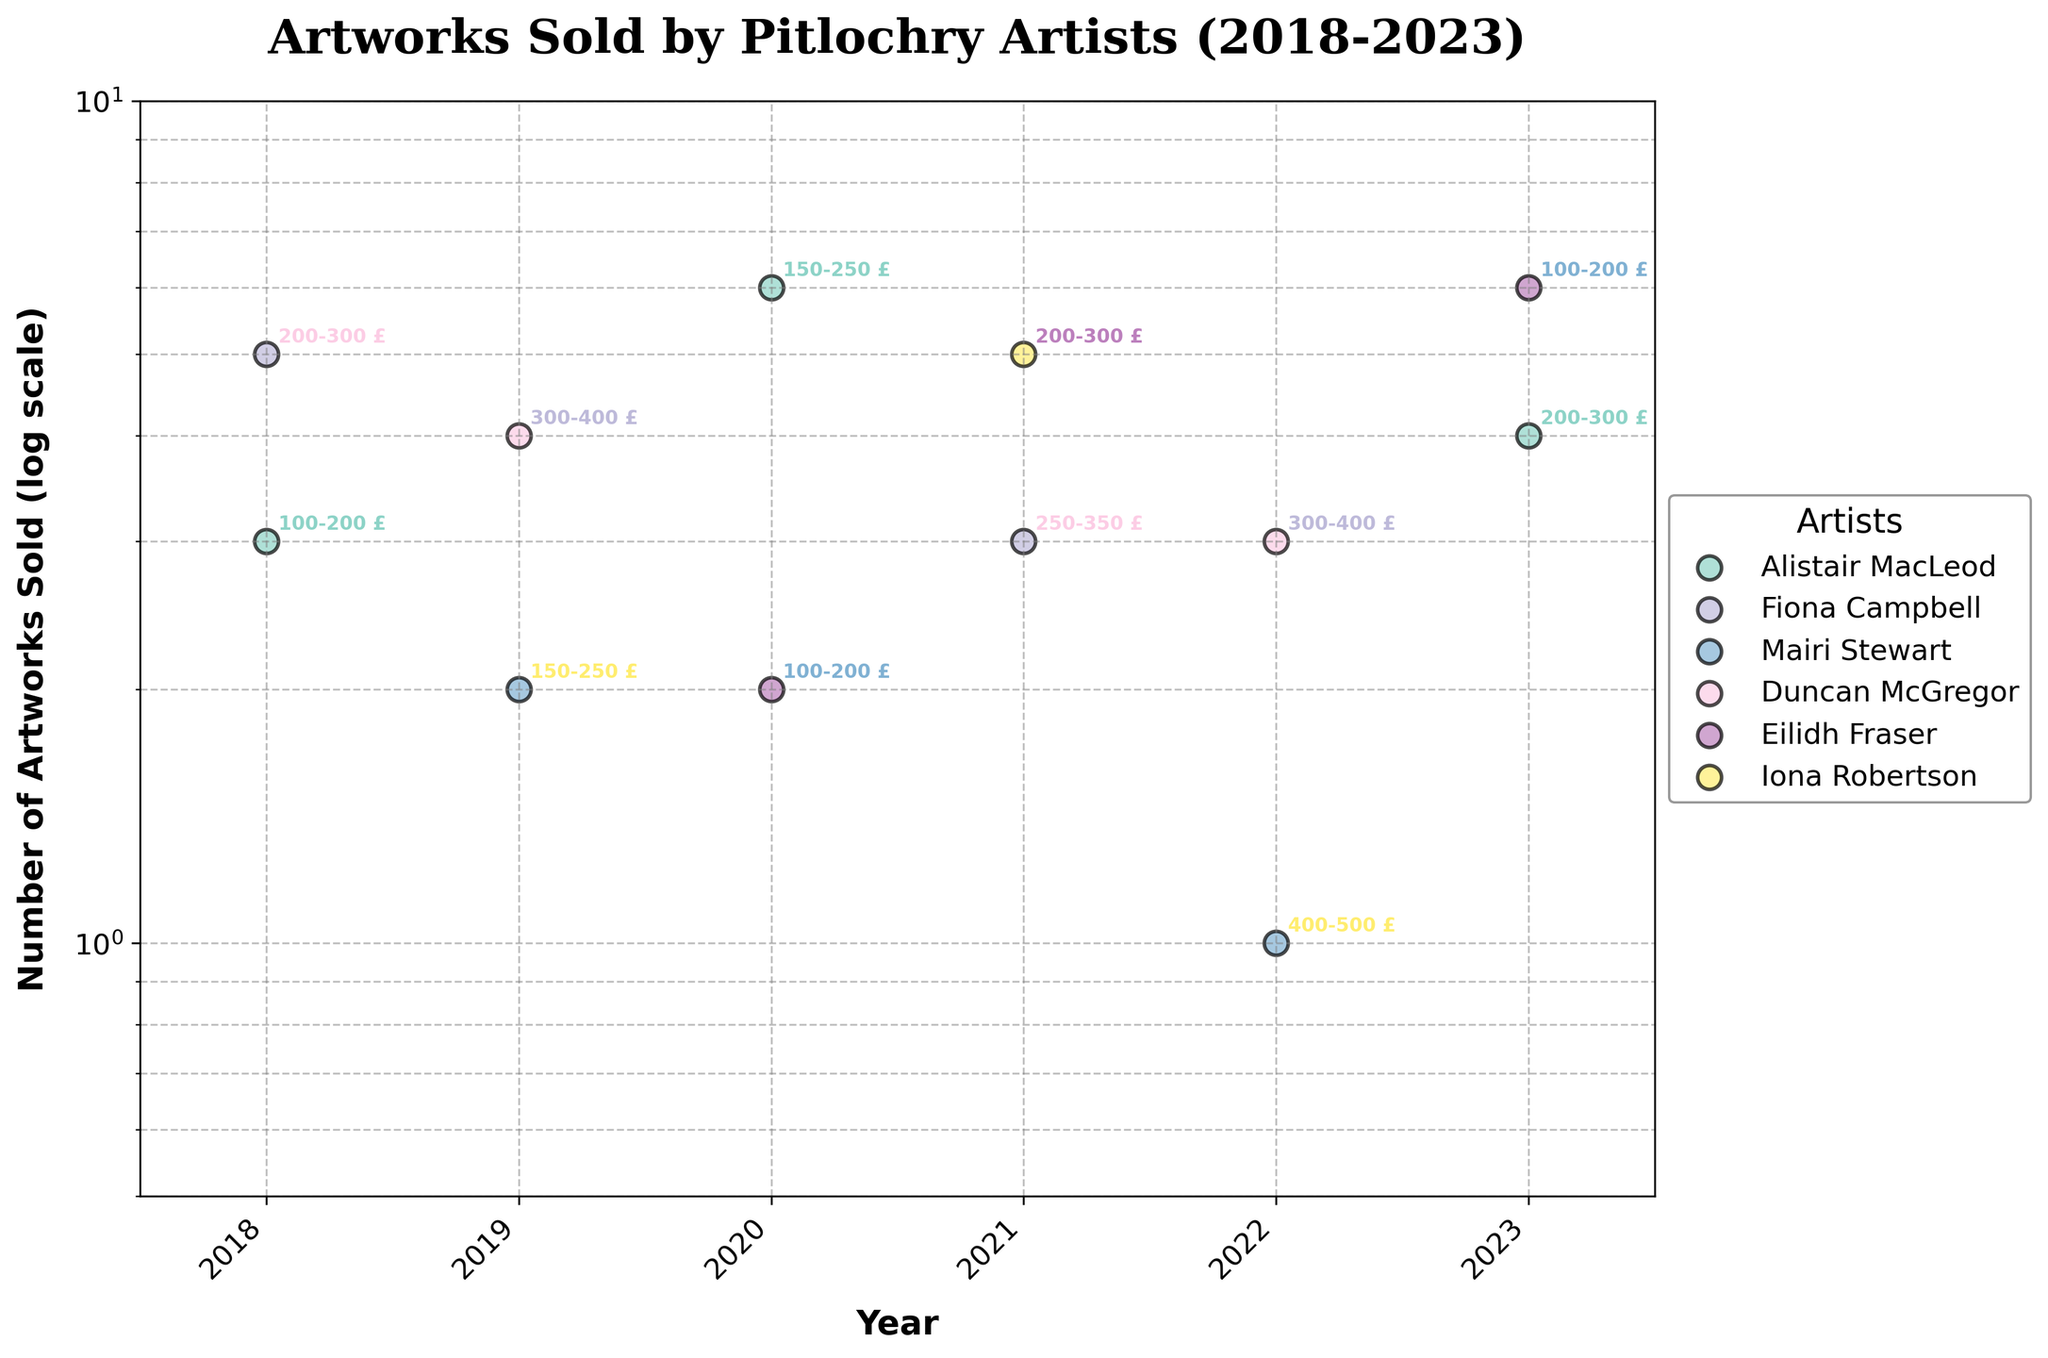what is the title of the figure? The title is usually positioned at the top of the figure in bold font. Here, the title is displayed as "Artworks Sold by Pitlochry Artists (2018-2023)", indicating the content and the time frame.
Answer: Artworks Sold by Pitlochry Artists (2018-2023) What is the value range of the log scale on the y-axis? By looking at the y-axis labels, we can see the numerical range, which starts from 0.5 and goes up to 10. This indicates the number of artworks sold on a log scale.
Answer: 0.5 to 10 Who sold the most artworks in 2020? To determine the artist who sold the most artworks in 2020, locate the 2020 data point on the x-axis and check the highest y-value among the dots. Alistair MacLeod has the highest value with 6 artworks sold.
Answer: Alistair MacLeod What is the price range for Duncan McGregor's sales in 2019 compared to 2022? To compare the price range, identify Duncan McGregor's data points for both years from the legend and see the annotated price ranges next to his data points. For 2019, it was 300-400 and for 2022, it is the same 300-400.
Answer: 300-400 in both years Which artist saw a significant increase in artworks sold between two consecutive years? To find an artist with a significant increase, look for the biggest vertical jump between data points of the same color in adjacent years. Eilidh Fraser increased from 2 in 2020 to 6 in 2023. This is the most notable increase.
Answer: Eilidh Fraser How many artworks were sold in total by Fiona Campbell? Sum the number of artworks sold by Fiona Campbell from the corresponding data points. For Fiona Campbell, it’s 5 in 2018, and 3 in 2021, totaling 8 artworks sold.
Answer: 8 Which year saw the highest number of artworks sold collectively by all artists? Sum the y-values for all artists in each year and see which year has the highest total. The year 2020 has the highest sum with Alistair MacLeod (6), and Eilidh Fraser (2), totaling 8 artworks.
Answer: 2020 What can you infer about the trend in sales for Mairi Stewart? Look at the data points for Mairi Stewart over various years and observe the trend. The sales data points for Mairi are 2 in 2019, and 1 in 2022, indicating a decrease in sales.
Answer: Decreasing trend How many distinct artists are represented in the figure? Count the unique artist names in the legend of the plot. There are six distinct artists represented: Alistair MacLeod, Fiona Campbell, Mairi Stewart, Duncan McGregor, Eilidh Fraser, and Iona Robertson.
Answer: 6 Which artist consistently sold artworks in different years, as seen from the figure? Identify artists whose data points appear across multiple years. Alistair MacLeod appears in 2018, 2020, and 2023, indicating consistent sales across these years.
Answer: Alistair MacLeod 